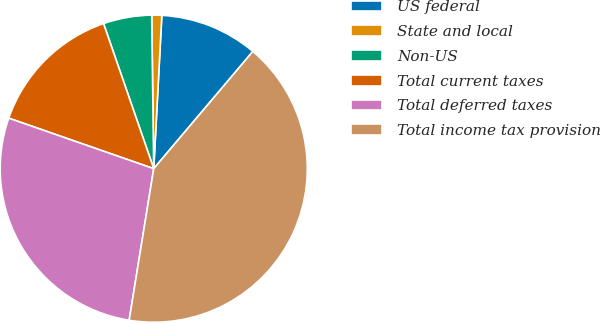Convert chart to OTSL. <chart><loc_0><loc_0><loc_500><loc_500><pie_chart><fcel>US federal<fcel>State and local<fcel>Non-US<fcel>Total current taxes<fcel>Total deferred taxes<fcel>Total income tax provision<nl><fcel>10.33%<fcel>1.05%<fcel>5.09%<fcel>14.36%<fcel>27.78%<fcel>41.39%<nl></chart> 